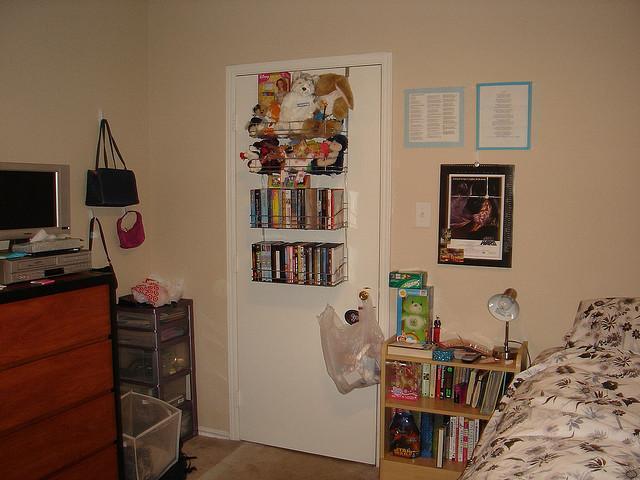How many books can be seen?
Give a very brief answer. 3. 